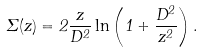<formula> <loc_0><loc_0><loc_500><loc_500>\Sigma ( z ) = 2 \frac { z } { D ^ { 2 } } \ln \left ( 1 + \frac { D ^ { 2 } } { z ^ { 2 } } \right ) .</formula> 